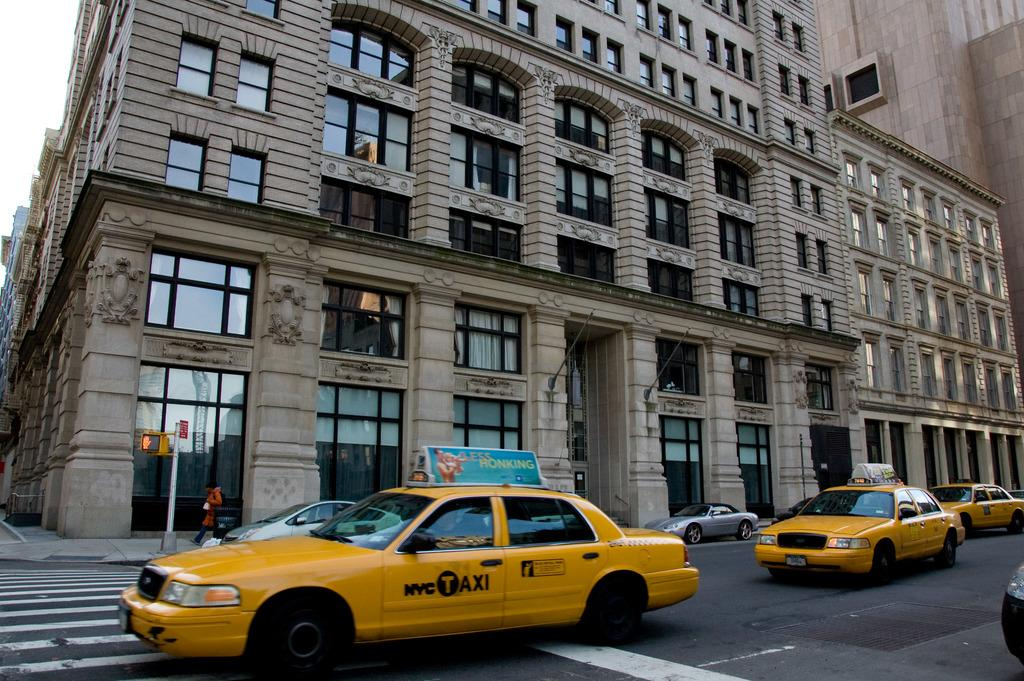Provide a one-sentence caption for the provided image. A NYC Taxi has a sign on the top of the vehicle that says less honking. 